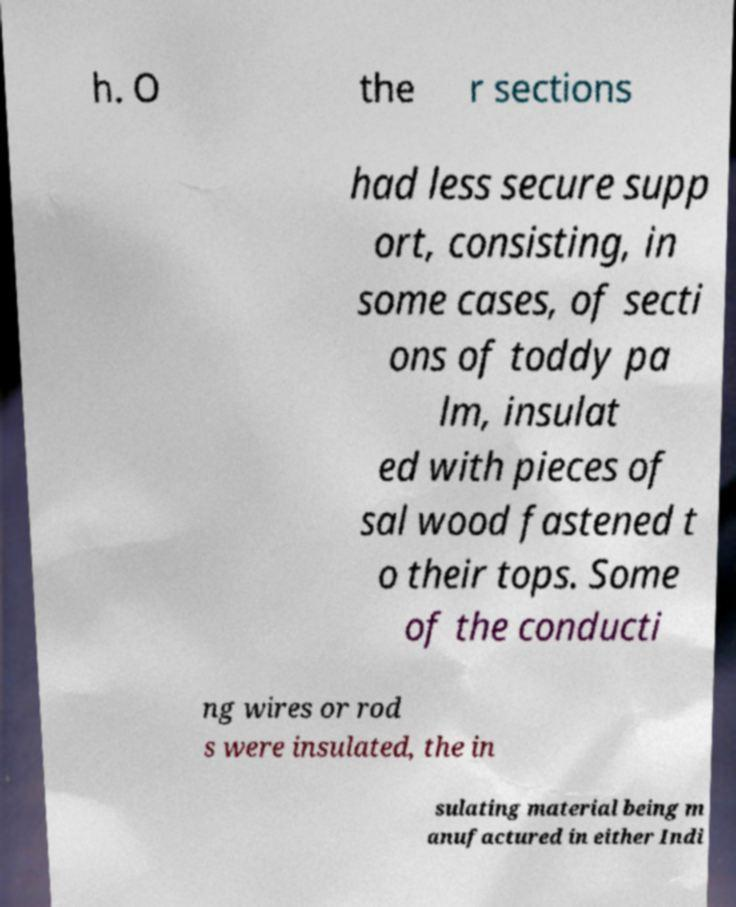Could you assist in decoding the text presented in this image and type it out clearly? h. O the r sections had less secure supp ort, consisting, in some cases, of secti ons of toddy pa lm, insulat ed with pieces of sal wood fastened t o their tops. Some of the conducti ng wires or rod s were insulated, the in sulating material being m anufactured in either Indi 